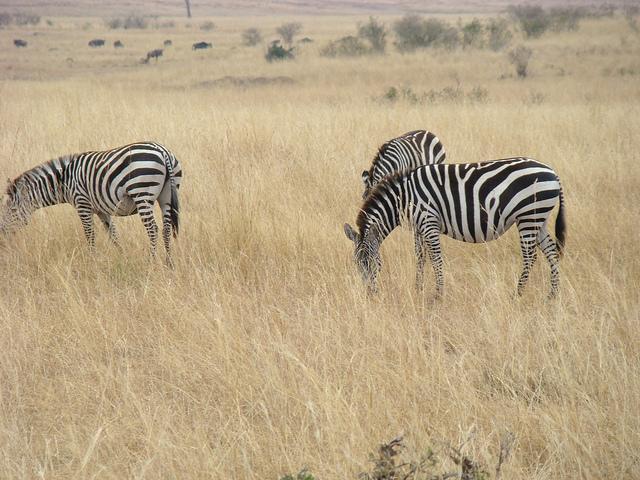How many zebra are in the picture?
Give a very brief answer. 3. How many zebras can be seen?
Give a very brief answer. 3. How many zebras are visible?
Give a very brief answer. 3. 